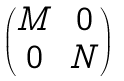Convert formula to latex. <formula><loc_0><loc_0><loc_500><loc_500>\begin{pmatrix} M & 0 \\ 0 & N \end{pmatrix}</formula> 